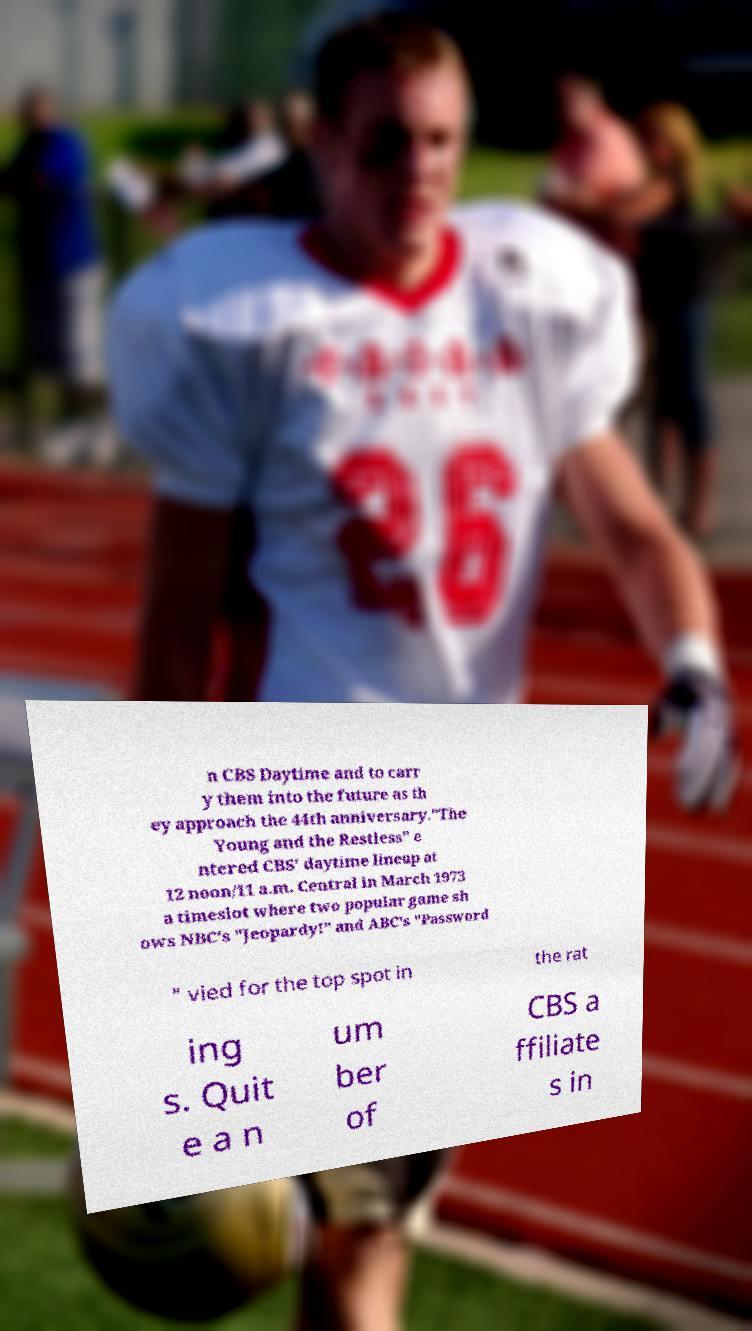For documentation purposes, I need the text within this image transcribed. Could you provide that? n CBS Daytime and to carr y them into the future as th ey approach the 44th anniversary."The Young and the Restless" e ntered CBS' daytime lineup at 12 noon/11 a.m. Central in March 1973 a timeslot where two popular game sh ows NBC's "Jeopardy!" and ABC's "Password " vied for the top spot in the rat ing s. Quit e a n um ber of CBS a ffiliate s in 